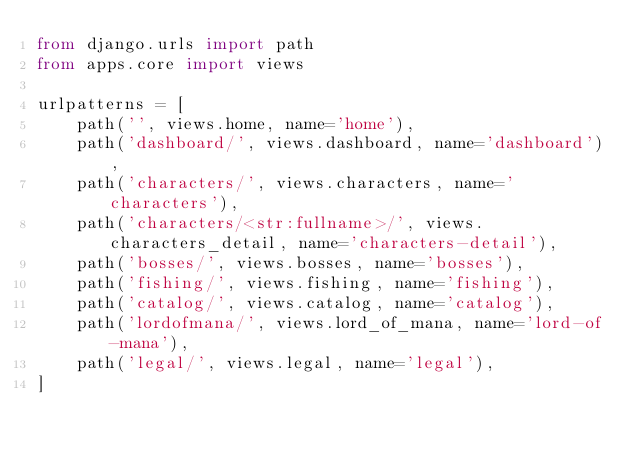<code> <loc_0><loc_0><loc_500><loc_500><_Python_>from django.urls import path
from apps.core import views

urlpatterns = [
    path('', views.home, name='home'),
    path('dashboard/', views.dashboard, name='dashboard'),
    path('characters/', views.characters, name='characters'),
    path('characters/<str:fullname>/', views.characters_detail, name='characters-detail'),
    path('bosses/', views.bosses, name='bosses'),
    path('fishing/', views.fishing, name='fishing'),
    path('catalog/', views.catalog, name='catalog'),
    path('lordofmana/', views.lord_of_mana, name='lord-of-mana'),
    path('legal/', views.legal, name='legal'),
]
</code> 